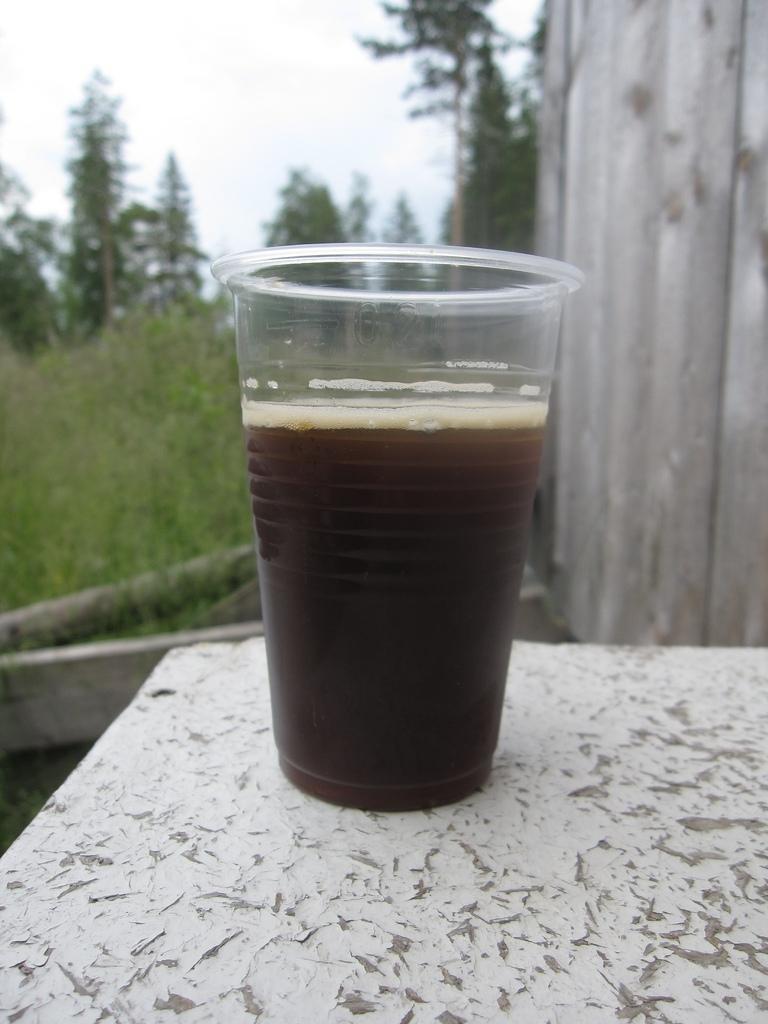Please provide a concise description of this image. In this image I can see in the middle a transparent glass with liquid in it. At the back side there are trees, on the right side it looks like a wooden wall. At the top it is the sky. 